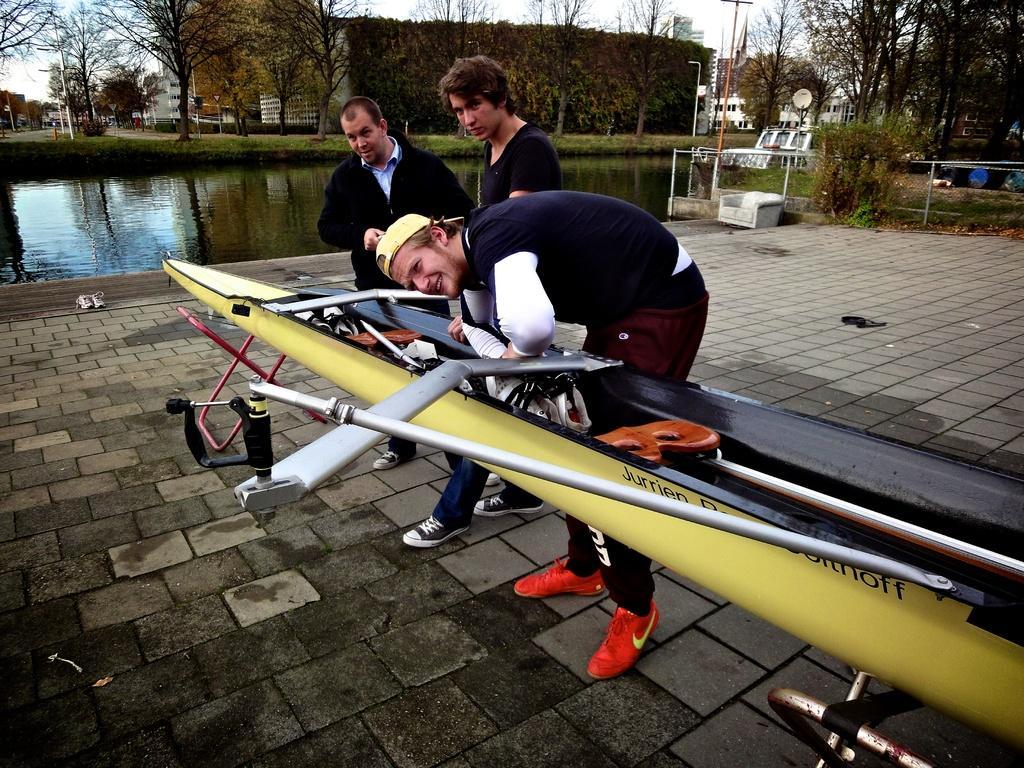Could you give a brief overview of what you see in this image? In this picture there is a man who is wearing t-shirt, cap and shoe, beside him there is another man who is standing near to this objects. On the water there is a ship. At the top there is a sky. 